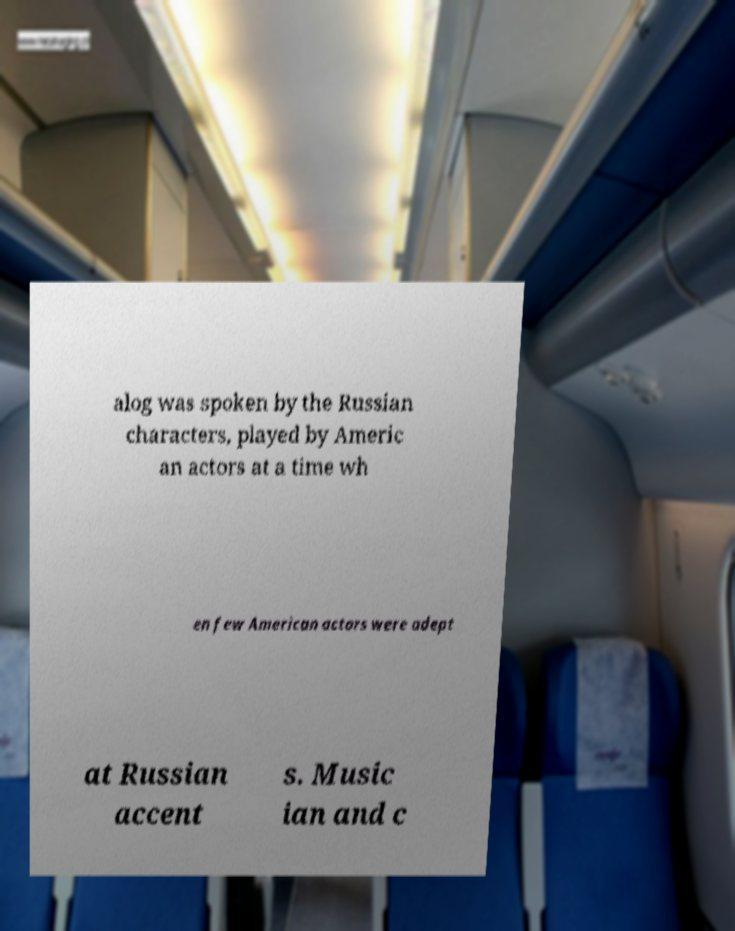Can you accurately transcribe the text from the provided image for me? alog was spoken by the Russian characters, played by Americ an actors at a time wh en few American actors were adept at Russian accent s. Music ian and c 